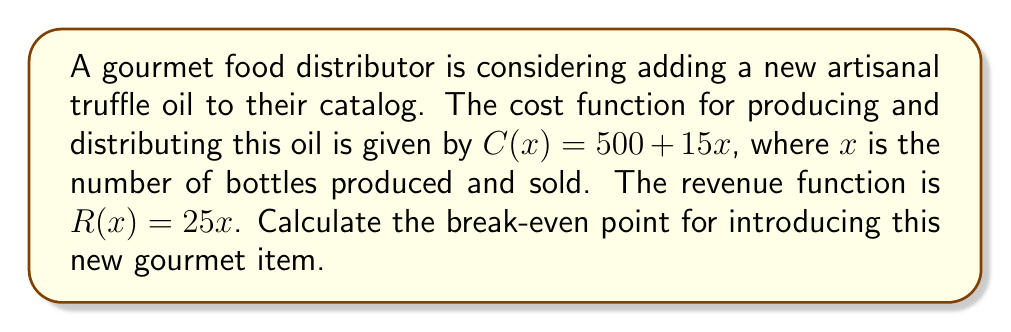Show me your answer to this math problem. To find the break-even point, we need to determine where the cost function equals the revenue function. At this point, the profit is zero.

1) Set up the equation:
   $C(x) = R(x)$
   $500 + 15x = 25x$

2) Solve for x:
   $500 + 15x = 25x$
   $500 = 25x - 15x$
   $500 = 10x$
   $x = 50$

3) Verify by calculating profit at x = 50:
   Revenue: $R(50) = 25(50) = 1250$
   Cost: $C(50) = 500 + 15(50) = 1250$
   Profit = Revenue - Cost = 1250 - 1250 = 0$

4) Interpret the result:
   The break-even point occurs when 50 bottles are sold. At this point, the revenue and costs are both $1250, resulting in zero profit.

[asy]
size(200,200);
import graph;

real f(real x) {return 500+15x;}
real g(real x) {return 25x;}

draw(graph(f,0,100),red,"Cost");
draw(graph(g,0,100),blue,"Revenue");

dot((50,1250));

label("Break-even point",(50,1250),NE);

xaxis("Quantity",0,100,Arrow);
yaxis("$",0,2500,Arrow);
[/asy]
Answer: The break-even point is 50 bottles. 